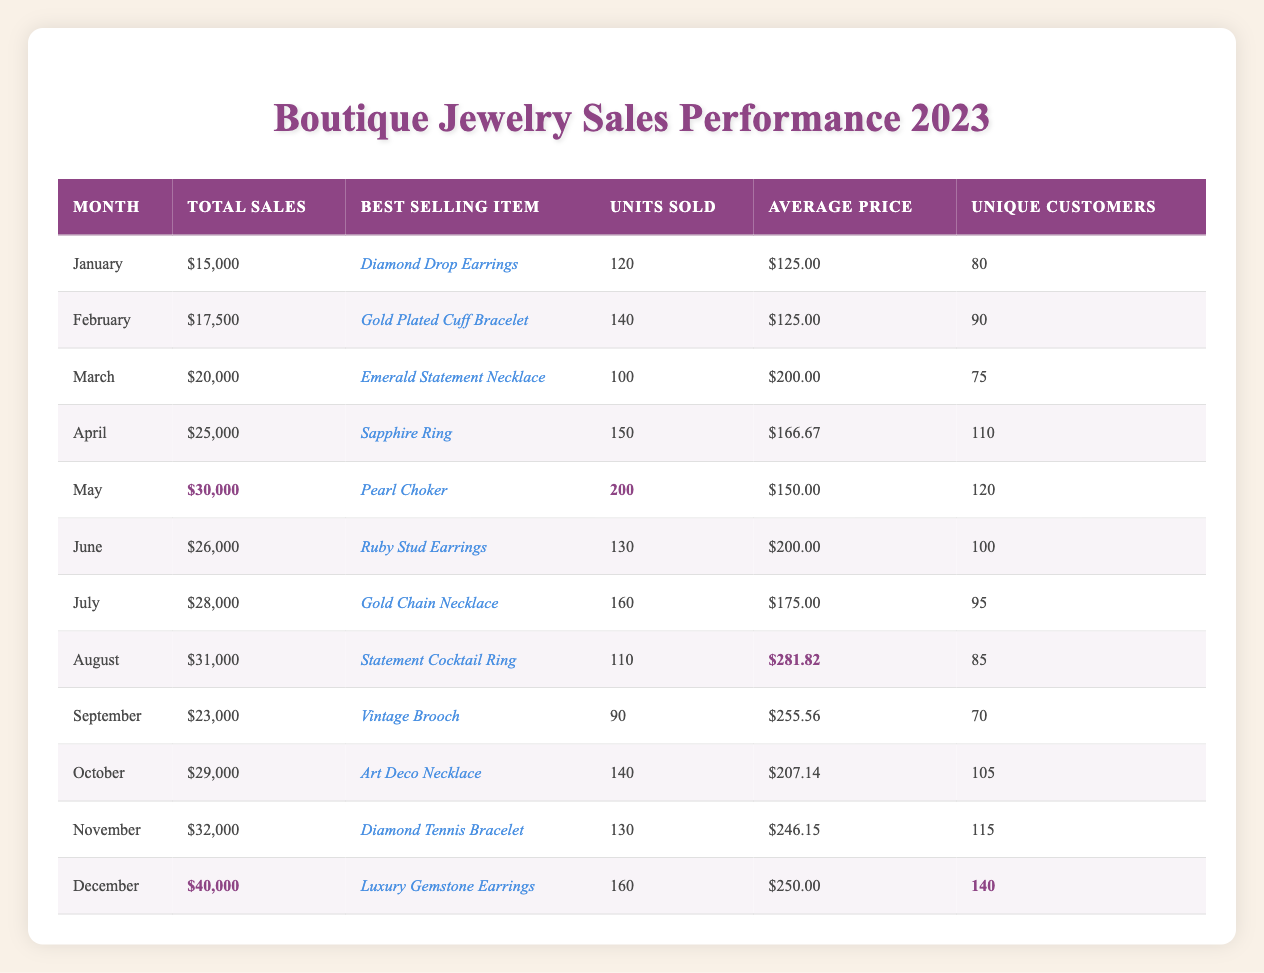What was the best-selling item in December? According to the table, the best-selling item in December is the "Luxury Gemstone Earrings".
Answer: Luxury Gemstone Earrings Which month had the highest total sales? The highest total sales were recorded in December, amounting to $40,000.
Answer: December How many unique customers were there in October? In October, there were 105 unique customers as per the table data.
Answer: 105 What was the average price of the best-selling item in May? The best-selling item in May was the "Pearl Choker", which had an average price of $150.00 according to the table.
Answer: $150.00 In which month were more than 150 units sold? More than 150 units were sold in April (150 units) and May (200 units), so May qualifies.
Answer: May How did the sales performance of June compare to July? June had total sales of $26,000, while July had total sales of $28,000. July performed better than June by $2,000.
Answer: July What is the average number of unique customers across the months from January to March? Adding unique customers for these months gives us 80 + 90 + 75 = 245. Dividing by 3 months, the average is 245 / 3 = 81.67.
Answer: 81.67 Was the average price of the best-selling items generally above or below $200? The average price of best-selling items needs to be calculated; adding their average prices gives $125.00 + $125.00 + $200.00 + $166.67 + $150.00 + $200.00 + $175.00 + $281.82 + $255.56 + $207.14 + $246.15 + $250.00 = $2,294.34, then divide by 12 months yields approximately $191.19, which is below $200.
Answer: Below $200 Which month saw the greatest increase in total sales compared to the previous month? The greatest increase occurred in December, which had total sales of $40,000 compared to November's $32,000, resulting in an increase of $8,000.
Answer: December What percentage of total sales in May compared to total sales in January? The total sales in May were $30,000, and in January, they were $15,000. The percentage is calculated as (30,000 / 15,000) * 100 = 200%.
Answer: 200% How many more units sold were there in December compared to September? In December, 160 units were sold, while in September, 90 units were sold. The difference is 160 - 90 = 70 units.
Answer: 70 units 